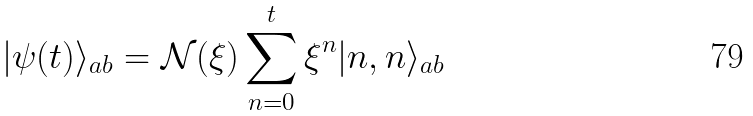Convert formula to latex. <formula><loc_0><loc_0><loc_500><loc_500>| \psi ( t ) \rangle _ { a b } = \mathcal { N } ( \xi ) \sum _ { n = 0 } ^ { t } \xi ^ { n } | n , n \rangle _ { a b }</formula> 